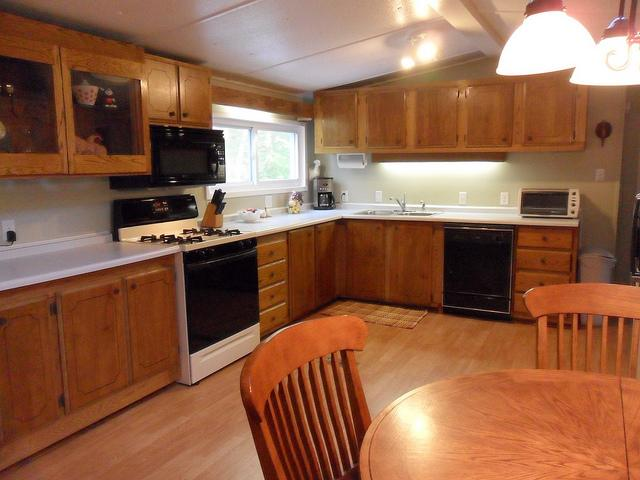What is the silver appliance near the window used to make?

Choices:
A) coffee
B) donuts
C) bread
D) ice cream coffee 